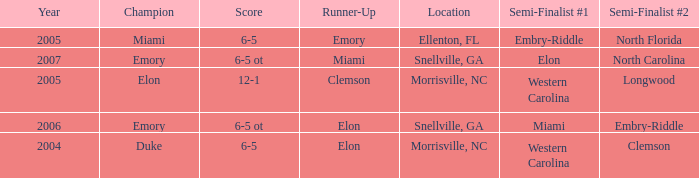Which team was the second semi finalist in 2007? North Carolina. 